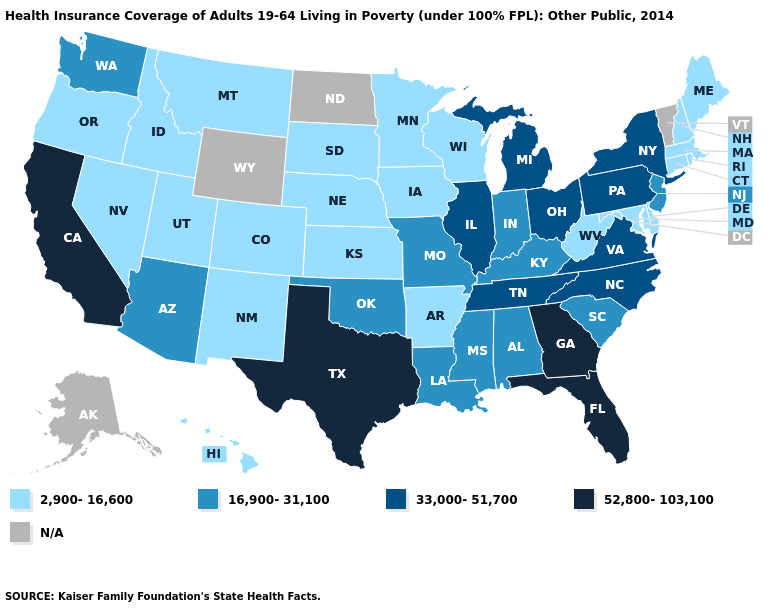What is the value of Delaware?
Give a very brief answer. 2,900-16,600. Which states have the highest value in the USA?
Give a very brief answer. California, Florida, Georgia, Texas. Which states hav the highest value in the West?
Be succinct. California. What is the value of Hawaii?
Quick response, please. 2,900-16,600. What is the lowest value in the USA?
Write a very short answer. 2,900-16,600. What is the lowest value in the USA?
Quick response, please. 2,900-16,600. What is the lowest value in the Northeast?
Short answer required. 2,900-16,600. Does the map have missing data?
Be succinct. Yes. What is the value of Alabama?
Concise answer only. 16,900-31,100. Is the legend a continuous bar?
Quick response, please. No. What is the value of Vermont?
Write a very short answer. N/A. What is the lowest value in the MidWest?
Concise answer only. 2,900-16,600. Name the states that have a value in the range 52,800-103,100?
Quick response, please. California, Florida, Georgia, Texas. What is the value of Virginia?
Concise answer only. 33,000-51,700. Among the states that border Minnesota , which have the highest value?
Give a very brief answer. Iowa, South Dakota, Wisconsin. 